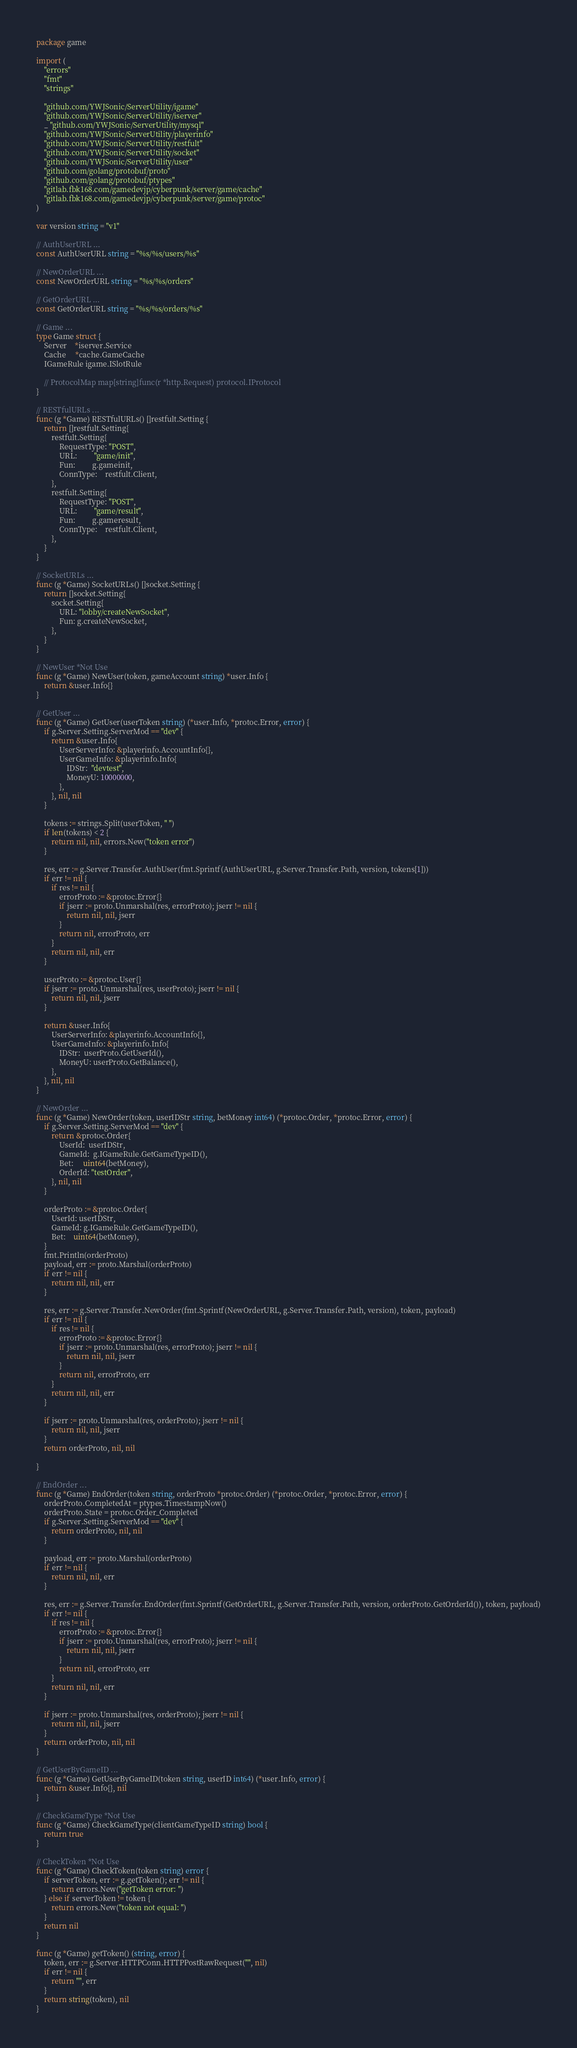<code> <loc_0><loc_0><loc_500><loc_500><_Go_>package game

import (
	"errors"
	"fmt"
	"strings"

	"github.com/YWJSonic/ServerUtility/igame"
	"github.com/YWJSonic/ServerUtility/iserver"
	_ "github.com/YWJSonic/ServerUtility/mysql"
	"github.com/YWJSonic/ServerUtility/playerinfo"
	"github.com/YWJSonic/ServerUtility/restfult"
	"github.com/YWJSonic/ServerUtility/socket"
	"github.com/YWJSonic/ServerUtility/user"
	"github.com/golang/protobuf/proto"
	"github.com/golang/protobuf/ptypes"
	"gitlab.fbk168.com/gamedevjp/cyberpunk/server/game/cache"
	"gitlab.fbk168.com/gamedevjp/cyberpunk/server/game/protoc"
)

var version string = "v1"

// AuthUserURL ...
const AuthUserURL string = "%s/%s/users/%s"

// NewOrderURL ...
const NewOrderURL string = "%s/%s/orders"

// GetOrderURL ...
const GetOrderURL string = "%s/%s/orders/%s"

// Game ...
type Game struct {
	Server    *iserver.Service
	Cache     *cache.GameCache
	IGameRule igame.ISlotRule

	// ProtocolMap map[string]func(r *http.Request) protocol.IProtocol
}

// RESTfulURLs ...
func (g *Game) RESTfulURLs() []restfult.Setting {
	return []restfult.Setting{
		restfult.Setting{
			RequestType: "POST",
			URL:         "game/init",
			Fun:         g.gameinit,
			ConnType:    restfult.Client,
		},
		restfult.Setting{
			RequestType: "POST",
			URL:         "game/result",
			Fun:         g.gameresult,
			ConnType:    restfult.Client,
		},
	}
}

// SocketURLs ...
func (g *Game) SocketURLs() []socket.Setting {
	return []socket.Setting{
		socket.Setting{
			URL: "lobby/createNewSocket",
			Fun: g.createNewSocket,
		},
	}
}

// NewUser *Not Use
func (g *Game) NewUser(token, gameAccount string) *user.Info {
	return &user.Info{}
}

// GetUser ...
func (g *Game) GetUser(userToken string) (*user.Info, *protoc.Error, error) {
	if g.Server.Setting.ServerMod == "dev" {
		return &user.Info{
			UserServerInfo: &playerinfo.AccountInfo{},
			UserGameInfo: &playerinfo.Info{
				IDStr:  "devtest",
				MoneyU: 10000000,
			},
		}, nil, nil
	}

	tokens := strings.Split(userToken, " ")
	if len(tokens) < 2 {
		return nil, nil, errors.New("token error")
	}

	res, err := g.Server.Transfer.AuthUser(fmt.Sprintf(AuthUserURL, g.Server.Transfer.Path, version, tokens[1]))
	if err != nil {
		if res != nil {
			errorProto := &protoc.Error{}
			if jserr := proto.Unmarshal(res, errorProto); jserr != nil {
				return nil, nil, jserr
			}
			return nil, errorProto, err
		}
		return nil, nil, err
	}

	userProto := &protoc.User{}
	if jserr := proto.Unmarshal(res, userProto); jserr != nil {
		return nil, nil, jserr
	}

	return &user.Info{
		UserServerInfo: &playerinfo.AccountInfo{},
		UserGameInfo: &playerinfo.Info{
			IDStr:  userProto.GetUserId(),
			MoneyU: userProto.GetBalance(),
		},
	}, nil, nil
}

// NewOrder ...
func (g *Game) NewOrder(token, userIDStr string, betMoney int64) (*protoc.Order, *protoc.Error, error) {
	if g.Server.Setting.ServerMod == "dev" {
		return &protoc.Order{
			UserId:  userIDStr,
			GameId:  g.IGameRule.GetGameTypeID(),
			Bet:     uint64(betMoney),
			OrderId: "testOrder",
		}, nil, nil
	}

	orderProto := &protoc.Order{
		UserId: userIDStr,
		GameId: g.IGameRule.GetGameTypeID(),
		Bet:    uint64(betMoney),
	}
	fmt.Println(orderProto)
	payload, err := proto.Marshal(orderProto)
	if err != nil {
		return nil, nil, err
	}

	res, err := g.Server.Transfer.NewOrder(fmt.Sprintf(NewOrderURL, g.Server.Transfer.Path, version), token, payload)
	if err != nil {
		if res != nil {
			errorProto := &protoc.Error{}
			if jserr := proto.Unmarshal(res, errorProto); jserr != nil {
				return nil, nil, jserr
			}
			return nil, errorProto, err
		}
		return nil, nil, err
	}

	if jserr := proto.Unmarshal(res, orderProto); jserr != nil {
		return nil, nil, jserr
	}
	return orderProto, nil, nil

}

// EndOrder ...
func (g *Game) EndOrder(token string, orderProto *protoc.Order) (*protoc.Order, *protoc.Error, error) {
	orderProto.CompletedAt = ptypes.TimestampNow()
	orderProto.State = protoc.Order_Completed
	if g.Server.Setting.ServerMod == "dev" {
		return orderProto, nil, nil
	}

	payload, err := proto.Marshal(orderProto)
	if err != nil {
		return nil, nil, err
	}

	res, err := g.Server.Transfer.EndOrder(fmt.Sprintf(GetOrderURL, g.Server.Transfer.Path, version, orderProto.GetOrderId()), token, payload)
	if err != nil {
		if res != nil {
			errorProto := &protoc.Error{}
			if jserr := proto.Unmarshal(res, errorProto); jserr != nil {
				return nil, nil, jserr
			}
			return nil, errorProto, err
		}
		return nil, nil, err
	}

	if jserr := proto.Unmarshal(res, orderProto); jserr != nil {
		return nil, nil, jserr
	}
	return orderProto, nil, nil
}

// GetUserByGameID ...
func (g *Game) GetUserByGameID(token string, userID int64) (*user.Info, error) {
	return &user.Info{}, nil
}

// CheckGameType *Not Use
func (g *Game) CheckGameType(clientGameTypeID string) bool {
	return true
}

// CheckToken *Not Use
func (g *Game) CheckToken(token string) error {
	if serverToken, err := g.getToken(); err != nil {
		return errors.New("getToken error: ")
	} else if serverToken != token {
		return errors.New("token not equal: ")
	}
	return nil
}

func (g *Game) getToken() (string, error) {
	token, err := g.Server.HTTPConn.HTTPPostRawRequest("", nil)
	if err != nil {
		return "", err
	}
	return string(token), nil
}
</code> 